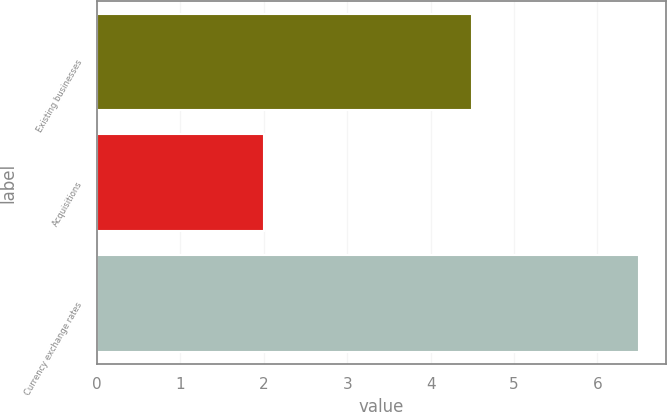Convert chart to OTSL. <chart><loc_0><loc_0><loc_500><loc_500><bar_chart><fcel>Existing businesses<fcel>Acquisitions<fcel>Currency exchange rates<nl><fcel>4.5<fcel>2<fcel>6.5<nl></chart> 